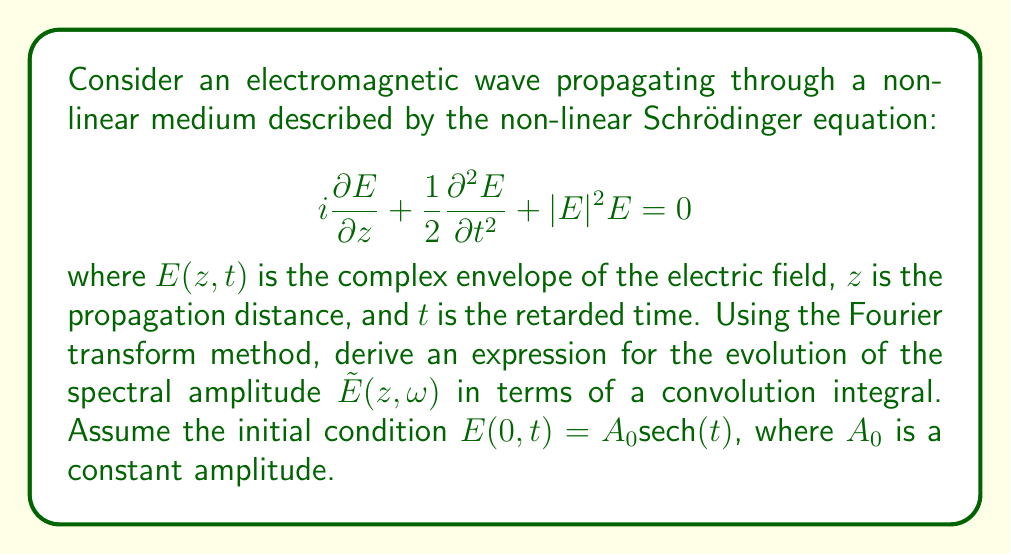Could you help me with this problem? To solve this problem, we'll follow these steps:

1) First, we need to apply the Fourier transform to the non-linear Schrödinger equation with respect to $t$. Let's denote the Fourier transform of $E(z,t)$ as $\tilde{E}(z,\omega)$:

   $$\mathcal{F}\left\{i\frac{\partial E}{\partial z} + \frac{1}{2}\frac{\partial^2 E}{\partial t^2} + |E|^2E\right\} = 0$$

2) Using the properties of Fourier transforms, we get:

   $$i\frac{\partial \tilde{E}}{\partial z} - \frac{1}{2}\omega^2\tilde{E} + \mathcal{F}\{|E|^2E\} = 0$$

3) The non-linear term $\mathcal{F}\{|E|^2E\}$ can be expressed as a convolution in the frequency domain:

   $$\mathcal{F}\{|E|^2E\} = \frac{1}{2\pi}\tilde{E} * \tilde{E}^* * \tilde{E}$$

   where $*$ denotes convolution and $\tilde{E}^*$ is the complex conjugate of $\tilde{E}$.

4) Substituting this back into the equation:

   $$i\frac{\partial \tilde{E}}{\partial z} - \frac{1}{2}\omega^2\tilde{E} + \frac{1}{2\pi}\tilde{E} * \tilde{E}^* * \tilde{E} = 0$$

5) This is the evolution equation for the spectral amplitude $\tilde{E}(z,\omega)$.

6) For the initial condition $E(0,t) = A_0\text{sech}(t)$, we need to find its Fourier transform:

   $$\tilde{E}(0,\omega) = A_0\pi\text{sech}\left(\frac{\pi\omega}{2}\right)$$

7) The evolution of $\tilde{E}(z,\omega)$ can then be expressed as:

   $$\tilde{E}(z,\omega) = \tilde{E}(0,\omega)\exp\left(i\frac{\omega^2}{2}z\right) + i\int_0^z \exp\left(i\frac{\omega^2}{2}(z-z')\right)\frac{1}{2\pi}\tilde{E} * \tilde{E}^* * \tilde{E}(z',\omega)dz'$$

This expression combines the linear evolution (first term) with the non-linear effects (integral term).
Answer: $\tilde{E}(z,\omega) = A_0\pi\text{sech}\left(\frac{\pi\omega}{2}\right)\exp\left(i\frac{\omega^2}{2}z\right) + i\int_0^z \exp\left(i\frac{\omega^2}{2}(z-z')\right)\frac{1}{2\pi}\tilde{E} * \tilde{E}^* * \tilde{E}(z',\omega)dz'$ 